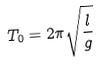<formula> <loc_0><loc_0><loc_500><loc_500>T _ { 0 } = 2 \pi \sqrt { \frac { l } { g } }</formula> 